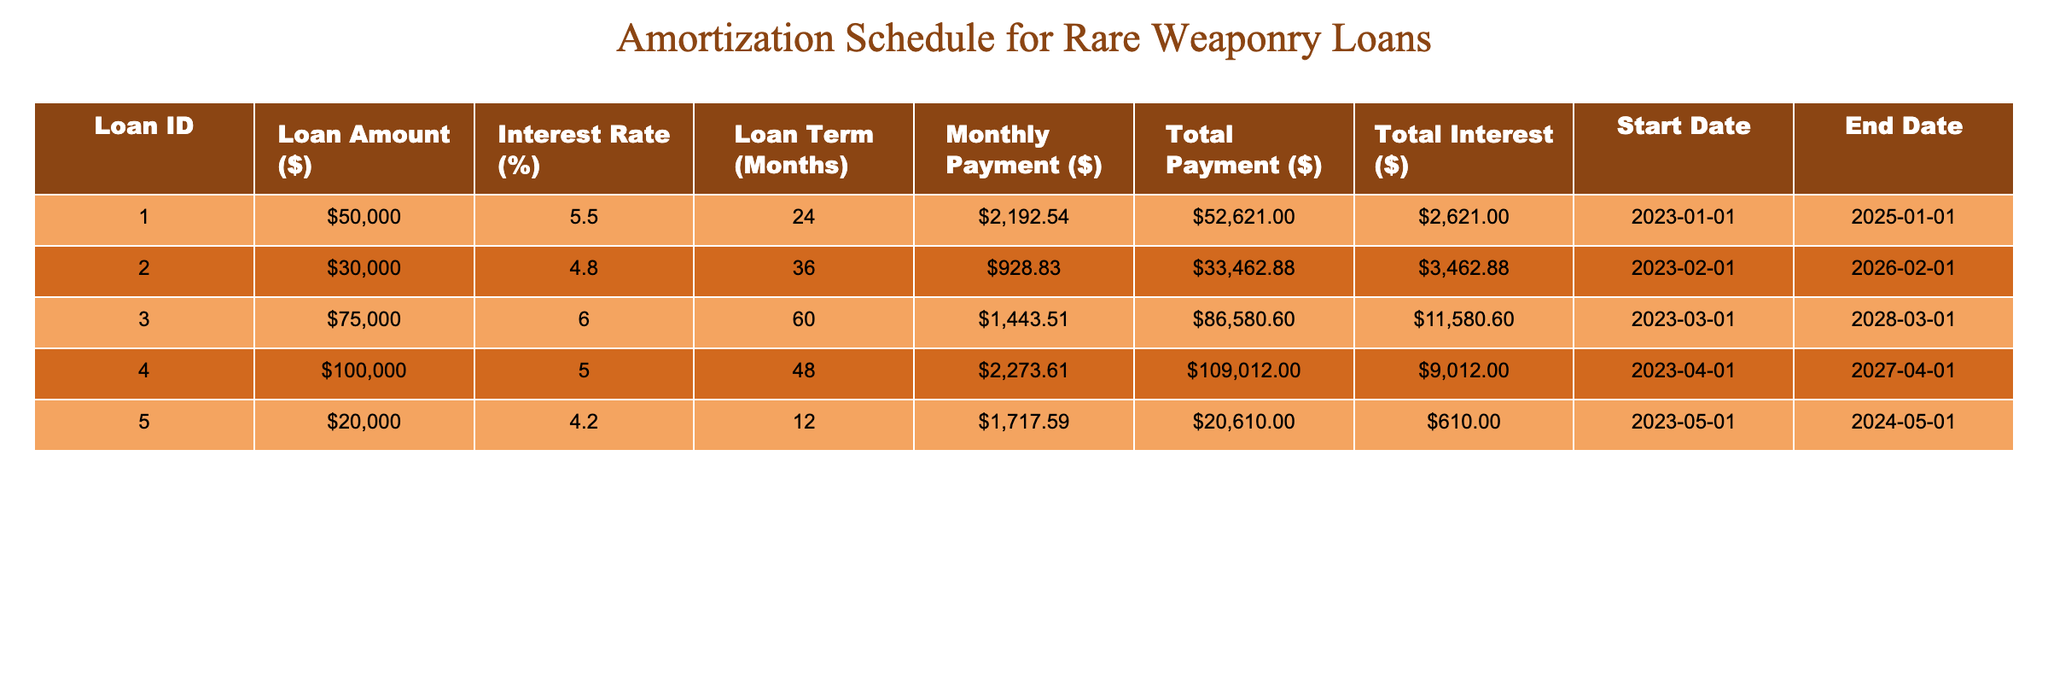What is the loan amount for Loan ID 003? The loan amount for Loan ID 003 is directly available in the table under the "Loan Amount ($)" column. It shows "$75000" for that particular loan.
Answer: $75000 How much total interest will be paid for Loan ID 002? The total interest for Loan ID 002 can be found in the "Total Interest ($)" column next to the corresponding loan ID, which lists "$3462.88".
Answer: $3462.88 Is the interest rate for Loan ID 004 higher than for Loan ID 005? Loan ID 004 has an interest rate of 5.0%, while Loan ID 005's interest rate is 4.2%. Since 5.0% is greater than 4.2%, the answer is yes.
Answer: Yes What is the average total payment across all loans? To find the average total payment, we first sum the "Total Payment ($)" values, which are $52621.00, $33462.88, $86580.60, $109012.00, and $20610.00, giving a total of $186886.48. Then we divide that by the number of loans (5) to find the average: $186886.48 / 5 = $37377.30.
Answer: $37377.30 How much more is the monthly payment for Loan ID 004 compared to Loan ID 001? The monthly payment for Loan ID 004 is $2273.61 and for Loan ID 001 it's $2192.54. To find the difference, we subtract the two monthly payments: $2273.61 - $2192.54 = $81.07.
Answer: $81.07 Which loan has the longest term, and what is the term length? Looking at the "Loan Term (Months)" column, Loan ID 003 has the longest term at 60 months, as that is the maximum value listed.
Answer: Loan ID 003, 60 months Is the total payment for Loan ID 005 less than $20,000? The total payment for Loan ID 005 is listed as $20610.00, which is greater than $20,000. Therefore, the answer is no.
Answer: No What is the total interest paid for Loan ID 001 and Loan ID 003 combined? The total interest for Loan ID 001 is $2621.00 and for Loan ID 003 it's $11580.60. We sum these values: $2621.00 + $11580.60 = $14201.60 to find the combined interest.
Answer: $14201.60 